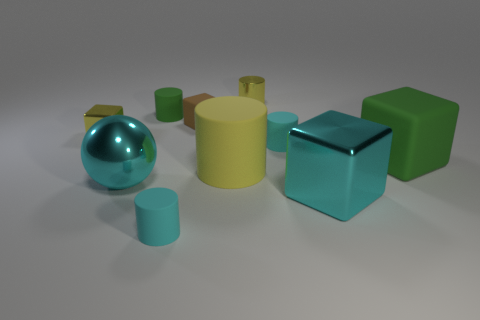Subtract all green cylinders. How many cylinders are left? 4 Subtract all large yellow matte cylinders. How many cylinders are left? 4 Subtract 1 blocks. How many blocks are left? 3 Subtract all gray cylinders. Subtract all yellow spheres. How many cylinders are left? 5 Subtract all blocks. How many objects are left? 6 Subtract all tiny green things. Subtract all big metallic cubes. How many objects are left? 8 Add 7 green cubes. How many green cubes are left? 8 Add 4 brown matte objects. How many brown matte objects exist? 5 Subtract 1 green cylinders. How many objects are left? 9 